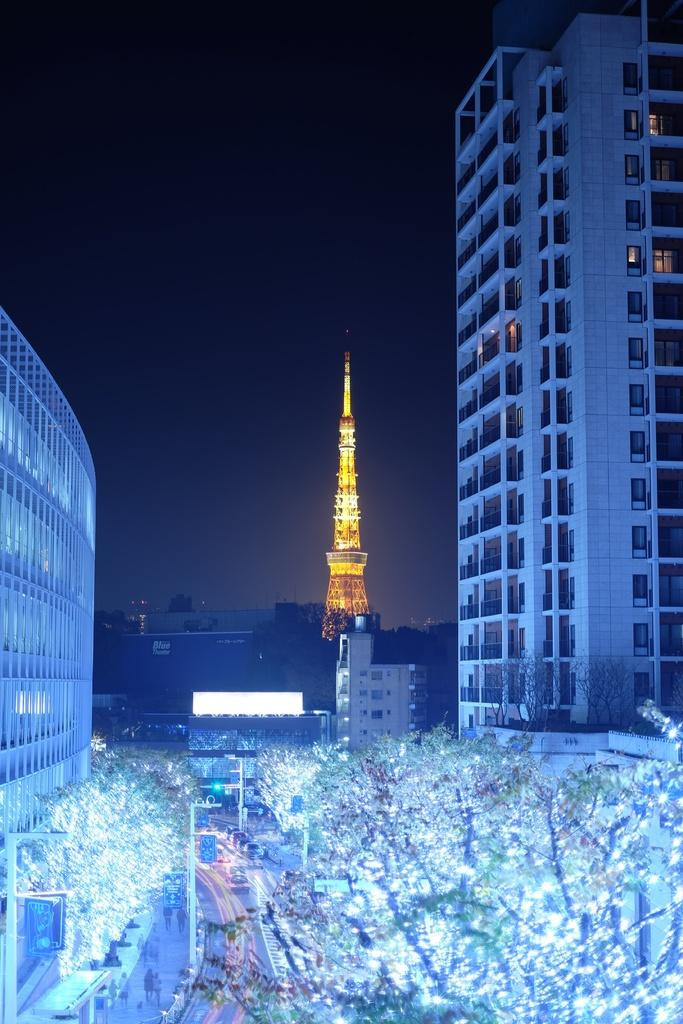What type of natural elements can be seen in the image? There are trees in the image. What type of man-made structures are present in the image? There are buildings in the image. What is used to decorate the trees in the image? Lights are present on the trees as decoration. Are there any people visible in the image? Yes, people are standing in the image. What type of bike can be seen being used for a specific activity in the image? There is no bike present in the image, so it cannot be used for any activity. What type of brush is being used by the people in the image? There is no brush visible in the image; the people are simply standing. 